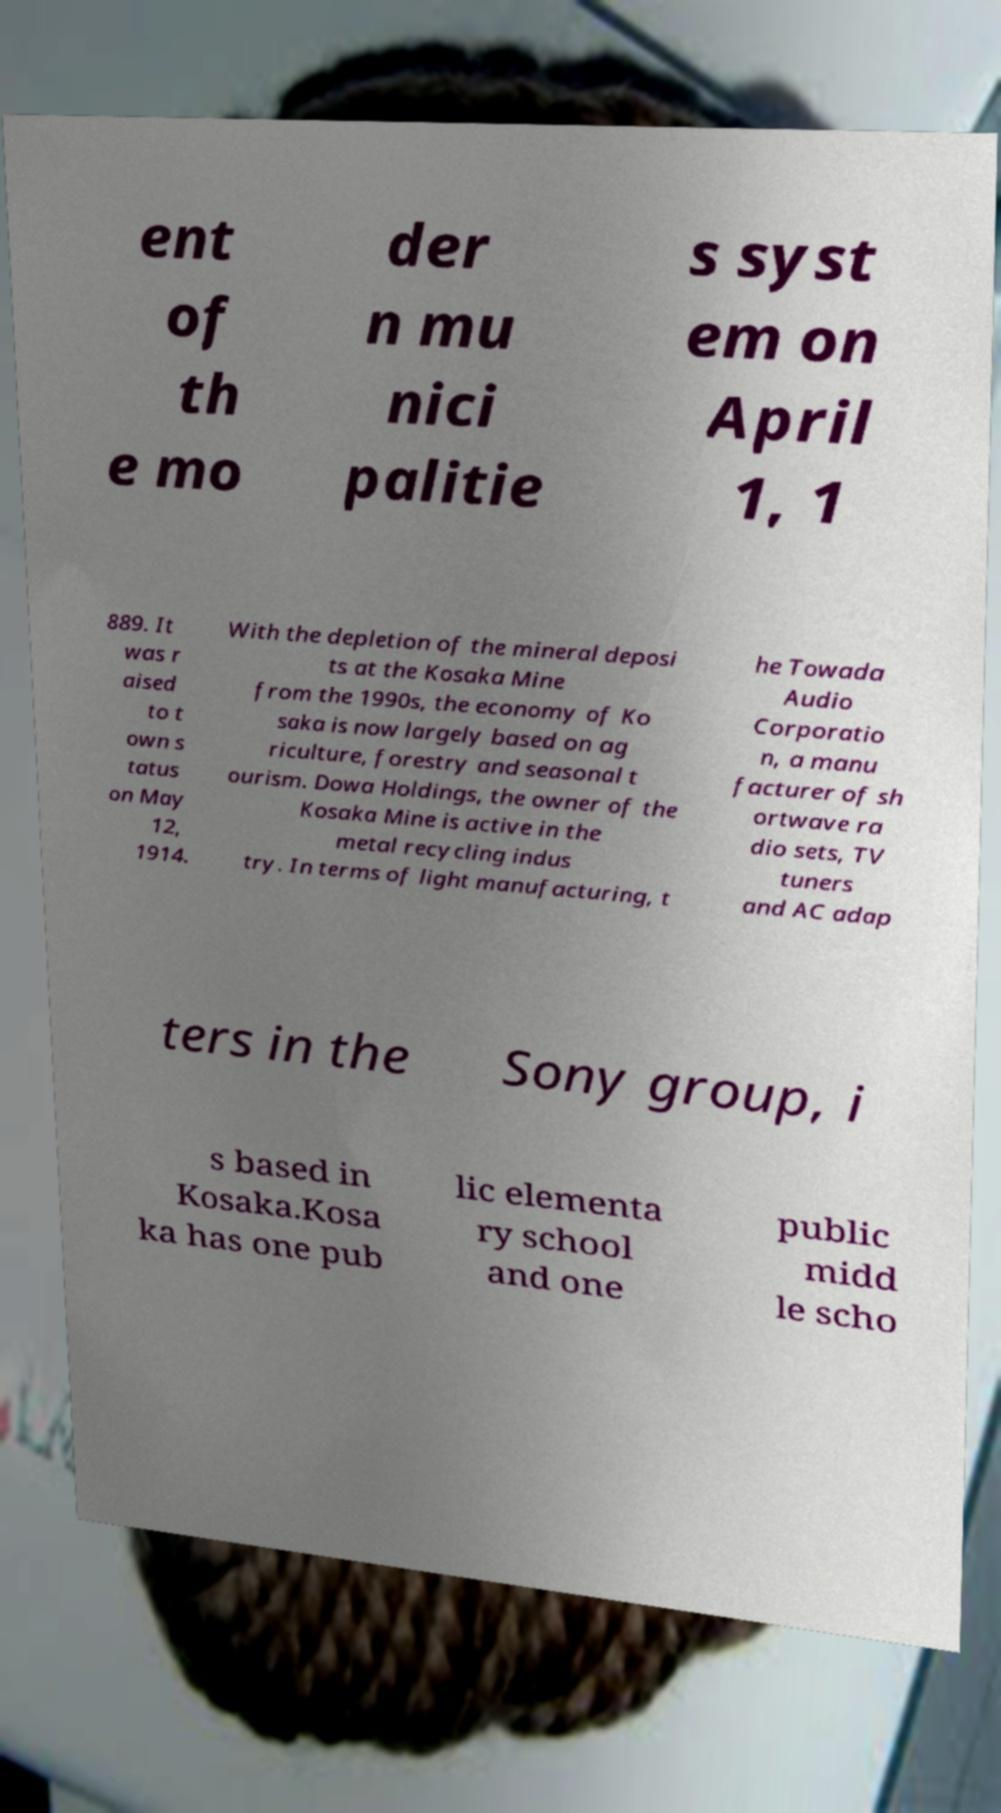Please identify and transcribe the text found in this image. ent of th e mo der n mu nici palitie s syst em on April 1, 1 889. It was r aised to t own s tatus on May 12, 1914. With the depletion of the mineral deposi ts at the Kosaka Mine from the 1990s, the economy of Ko saka is now largely based on ag riculture, forestry and seasonal t ourism. Dowa Holdings, the owner of the Kosaka Mine is active in the metal recycling indus try. In terms of light manufacturing, t he Towada Audio Corporatio n, a manu facturer of sh ortwave ra dio sets, TV tuners and AC adap ters in the Sony group, i s based in Kosaka.Kosa ka has one pub lic elementa ry school and one public midd le scho 